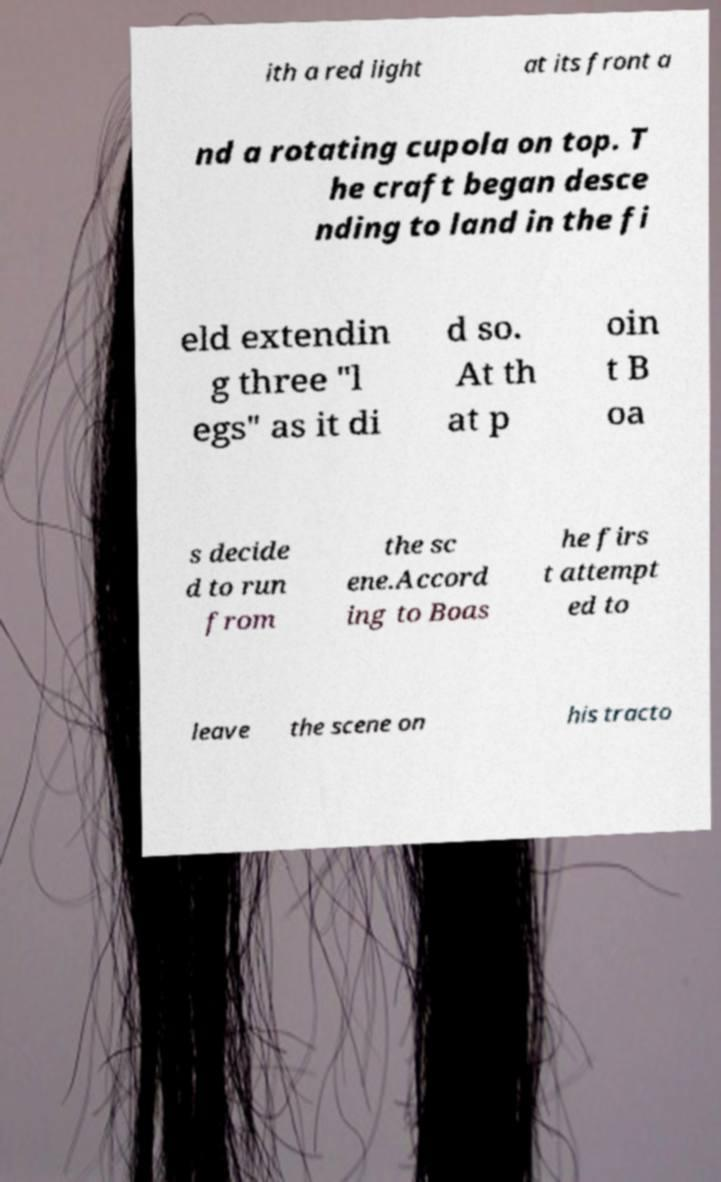For documentation purposes, I need the text within this image transcribed. Could you provide that? ith a red light at its front a nd a rotating cupola on top. T he craft began desce nding to land in the fi eld extendin g three "l egs" as it di d so. At th at p oin t B oa s decide d to run from the sc ene.Accord ing to Boas he firs t attempt ed to leave the scene on his tracto 